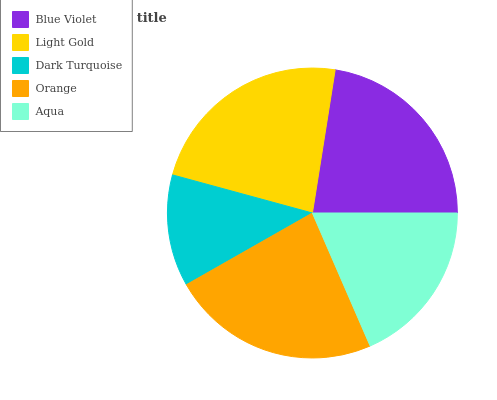Is Dark Turquoise the minimum?
Answer yes or no. Yes. Is Orange the maximum?
Answer yes or no. Yes. Is Light Gold the minimum?
Answer yes or no. No. Is Light Gold the maximum?
Answer yes or no. No. Is Light Gold greater than Blue Violet?
Answer yes or no. Yes. Is Blue Violet less than Light Gold?
Answer yes or no. Yes. Is Blue Violet greater than Light Gold?
Answer yes or no. No. Is Light Gold less than Blue Violet?
Answer yes or no. No. Is Blue Violet the high median?
Answer yes or no. Yes. Is Blue Violet the low median?
Answer yes or no. Yes. Is Dark Turquoise the high median?
Answer yes or no. No. Is Light Gold the low median?
Answer yes or no. No. 